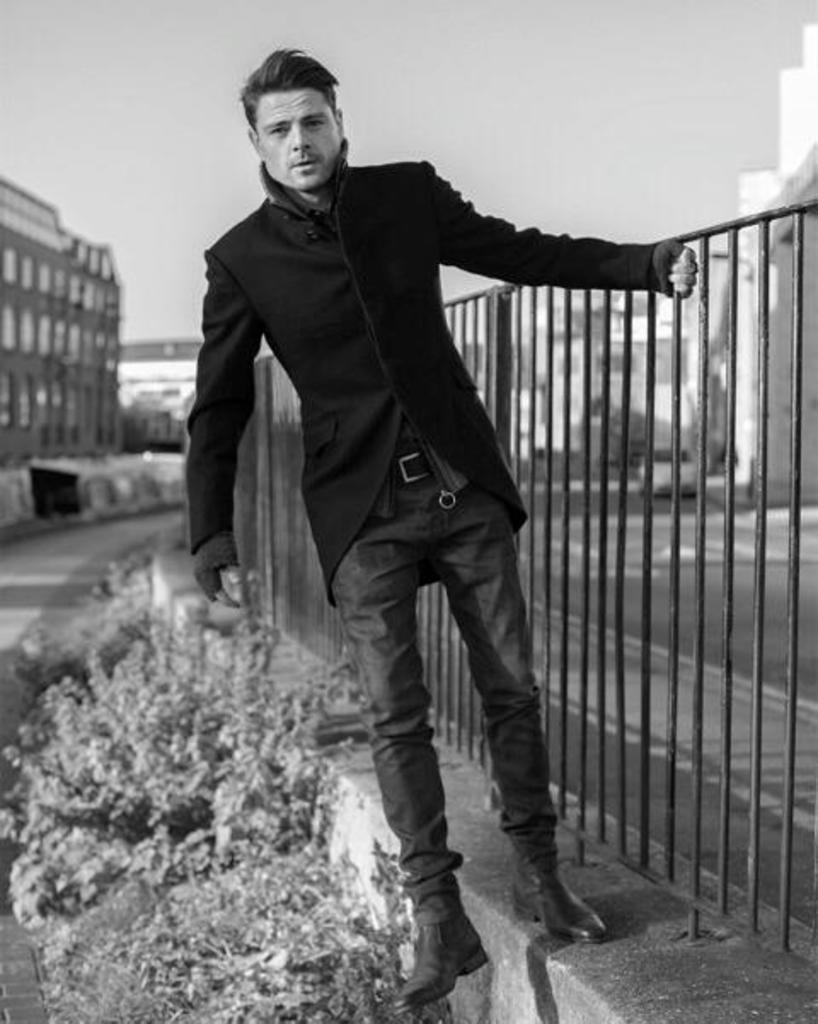What is the man doing in the image? The man is standing on the path in the image. What else can be seen on the path? There are plants on the path. What can be seen in the distance behind the man? There are buildings in the background of the image. How many fingers can be seen on the man's leg in the image? There are no fingers or legs visible on the man in the image; he is standing upright with his arms at his sides. 